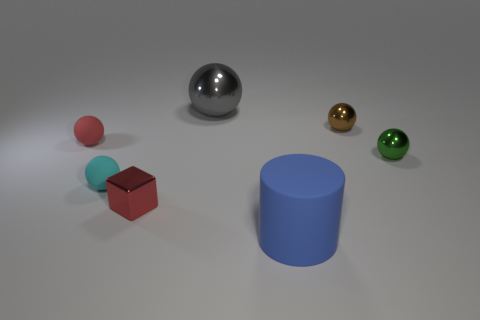Is the brown sphere the same size as the red block?
Provide a succinct answer. Yes. What shape is the cyan matte object that is the same size as the green object?
Provide a short and direct response. Sphere. There is a green shiny thing in front of the red sphere; does it have the same size as the small brown shiny sphere?
Offer a terse response. Yes. There is a green sphere that is the same size as the brown shiny sphere; what material is it?
Your answer should be compact. Metal. There is a big object that is in front of the small shiny object in front of the small green metallic thing; are there any metal objects that are to the right of it?
Provide a short and direct response. Yes. Is there any other thing that has the same shape as the big blue object?
Your answer should be compact. No. There is a tiny metallic thing left of the large blue object; is its color the same as the tiny rubber object behind the tiny green object?
Offer a very short reply. Yes. Is there a small metallic sphere?
Provide a short and direct response. Yes. There is a tiny thing that is the same color as the shiny cube; what material is it?
Make the answer very short. Rubber. What size is the rubber ball that is in front of the shiny thing that is on the right side of the small brown metallic thing that is to the right of the big shiny object?
Provide a succinct answer. Small. 